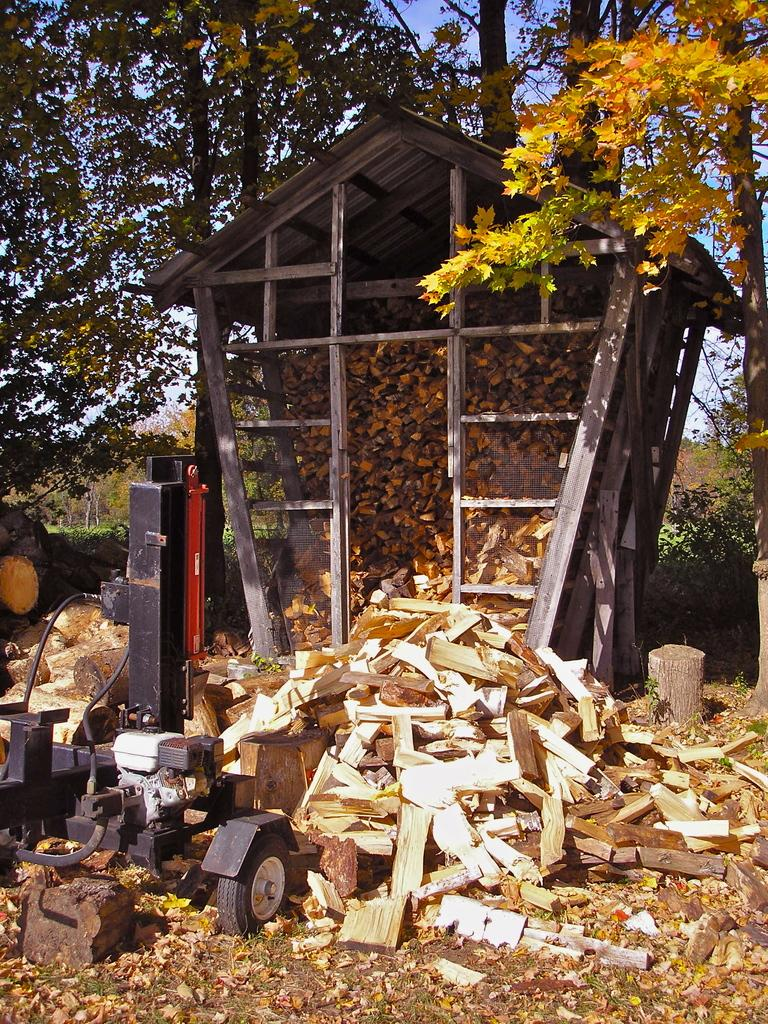What objects are in the center of the image? There are wooden blocks in the center of the image. What type of structure is visible in the image? There is a wooden structure in the image. What natural elements can be seen in the image? Trees are present in the image. What is located at the bottom of the image? Dry leaves and flowers are present at the bottom of the image. What direction is the wind blowing in the image? There is no indication of wind in the image, so it cannot be determined from the image. What type of street is visible in the image? There is no street present in the image; it features wooden blocks, a wooden structure, trees, and dry leaves and flowers. 